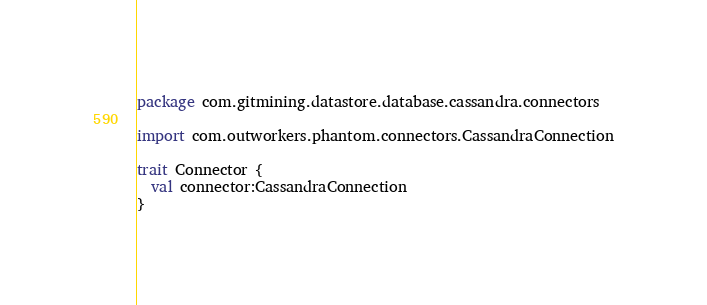<code> <loc_0><loc_0><loc_500><loc_500><_Scala_>package com.gitmining.datastore.database.cassandra.connectors

import com.outworkers.phantom.connectors.CassandraConnection

trait Connector {
  val connector:CassandraConnection
}
</code> 